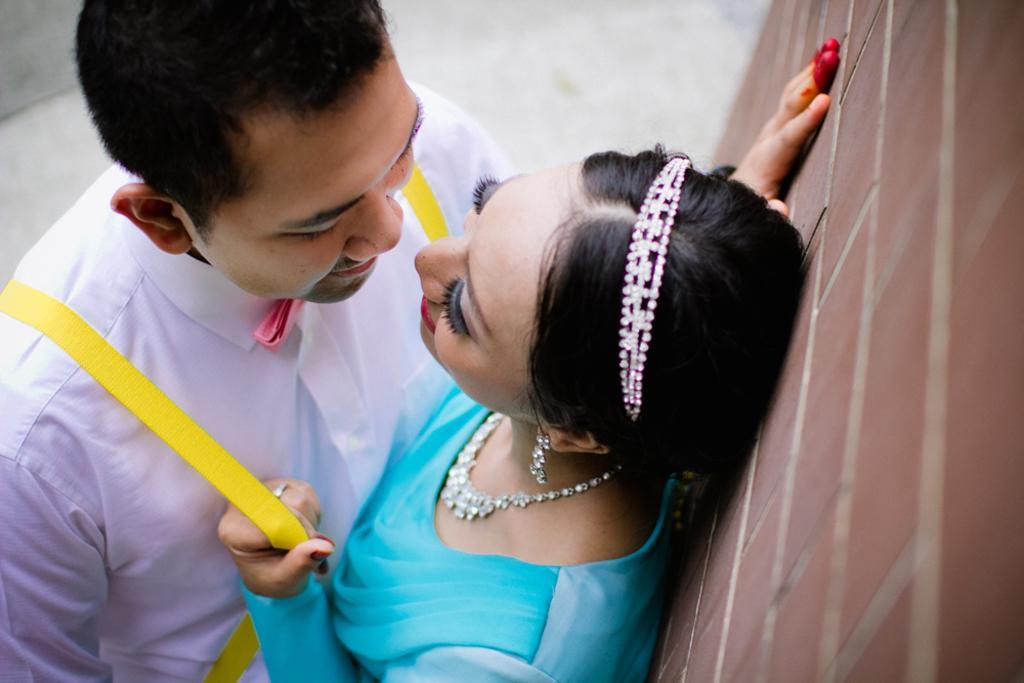Describe this image in one or two sentences. In this image there is a man and a woman standing. Behind the woman there is a wall. They are smiling. 